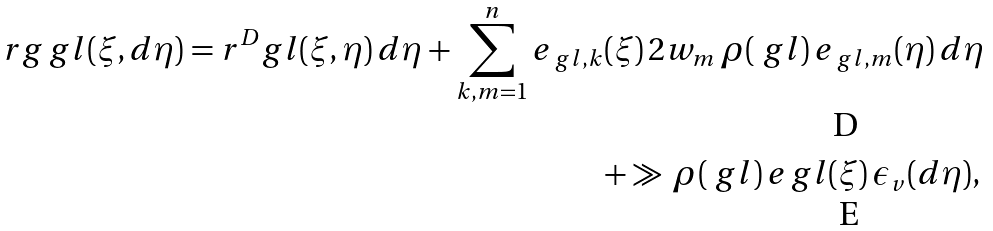<formula> <loc_0><loc_0><loc_500><loc_500>\ r g _ { \ } g l ( \xi , d \eta ) = r ^ { D } _ { \ } g l ( \xi , \eta ) \, d \eta + \sum _ { k , m = 1 } ^ { n } e _ { \ g l , k } & ( \xi ) \, 2 w _ { m } \, \rho ( \ g l ) \, e _ { \ g l , m } ( \eta ) \, d \eta \\ & + \gg \, \rho ( \ g l ) \, e _ { \ } g l ( \xi ) \, \epsilon _ { v } ( d \eta ) ,</formula> 